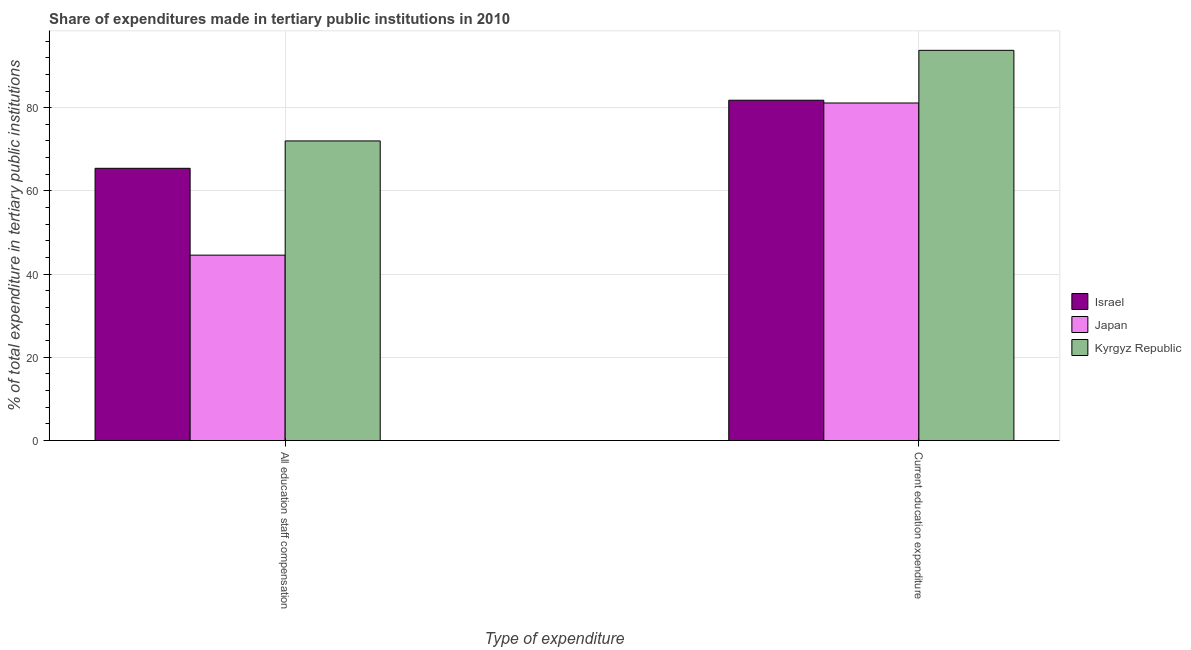How many different coloured bars are there?
Your answer should be compact. 3. How many groups of bars are there?
Give a very brief answer. 2. Are the number of bars on each tick of the X-axis equal?
Your answer should be compact. Yes. What is the label of the 2nd group of bars from the left?
Give a very brief answer. Current education expenditure. What is the expenditure in staff compensation in Japan?
Offer a very short reply. 44.56. Across all countries, what is the maximum expenditure in staff compensation?
Your answer should be compact. 72.01. Across all countries, what is the minimum expenditure in staff compensation?
Ensure brevity in your answer.  44.56. In which country was the expenditure in education maximum?
Your answer should be compact. Kyrgyz Republic. What is the total expenditure in staff compensation in the graph?
Make the answer very short. 181.99. What is the difference between the expenditure in education in Kyrgyz Republic and that in Japan?
Your response must be concise. 12.65. What is the difference between the expenditure in education in Japan and the expenditure in staff compensation in Kyrgyz Republic?
Make the answer very short. 9.12. What is the average expenditure in education per country?
Provide a succinct answer. 85.56. What is the difference between the expenditure in staff compensation and expenditure in education in Kyrgyz Republic?
Your answer should be very brief. -21.77. In how many countries, is the expenditure in education greater than 60 %?
Your answer should be very brief. 3. What is the ratio of the expenditure in education in Japan to that in Kyrgyz Republic?
Provide a succinct answer. 0.87. Is the expenditure in staff compensation in Israel less than that in Japan?
Provide a succinct answer. No. In how many countries, is the expenditure in education greater than the average expenditure in education taken over all countries?
Your answer should be compact. 1. What does the 3rd bar from the left in All education staff compensation represents?
Offer a very short reply. Kyrgyz Republic. How many countries are there in the graph?
Ensure brevity in your answer.  3. Does the graph contain any zero values?
Offer a terse response. No. Where does the legend appear in the graph?
Provide a short and direct response. Center right. What is the title of the graph?
Give a very brief answer. Share of expenditures made in tertiary public institutions in 2010. Does "Slovak Republic" appear as one of the legend labels in the graph?
Your answer should be compact. No. What is the label or title of the X-axis?
Your response must be concise. Type of expenditure. What is the label or title of the Y-axis?
Your answer should be very brief. % of total expenditure in tertiary public institutions. What is the % of total expenditure in tertiary public institutions of Israel in All education staff compensation?
Keep it short and to the point. 65.43. What is the % of total expenditure in tertiary public institutions in Japan in All education staff compensation?
Ensure brevity in your answer.  44.56. What is the % of total expenditure in tertiary public institutions of Kyrgyz Republic in All education staff compensation?
Your response must be concise. 72.01. What is the % of total expenditure in tertiary public institutions in Israel in Current education expenditure?
Offer a terse response. 81.78. What is the % of total expenditure in tertiary public institutions in Japan in Current education expenditure?
Give a very brief answer. 81.12. What is the % of total expenditure in tertiary public institutions of Kyrgyz Republic in Current education expenditure?
Give a very brief answer. 93.77. Across all Type of expenditure, what is the maximum % of total expenditure in tertiary public institutions in Israel?
Your response must be concise. 81.78. Across all Type of expenditure, what is the maximum % of total expenditure in tertiary public institutions in Japan?
Make the answer very short. 81.12. Across all Type of expenditure, what is the maximum % of total expenditure in tertiary public institutions in Kyrgyz Republic?
Ensure brevity in your answer.  93.77. Across all Type of expenditure, what is the minimum % of total expenditure in tertiary public institutions of Israel?
Provide a succinct answer. 65.43. Across all Type of expenditure, what is the minimum % of total expenditure in tertiary public institutions of Japan?
Give a very brief answer. 44.56. Across all Type of expenditure, what is the minimum % of total expenditure in tertiary public institutions of Kyrgyz Republic?
Provide a short and direct response. 72.01. What is the total % of total expenditure in tertiary public institutions in Israel in the graph?
Your answer should be very brief. 147.21. What is the total % of total expenditure in tertiary public institutions of Japan in the graph?
Provide a succinct answer. 125.68. What is the total % of total expenditure in tertiary public institutions in Kyrgyz Republic in the graph?
Ensure brevity in your answer.  165.78. What is the difference between the % of total expenditure in tertiary public institutions of Israel in All education staff compensation and that in Current education expenditure?
Your response must be concise. -16.36. What is the difference between the % of total expenditure in tertiary public institutions in Japan in All education staff compensation and that in Current education expenditure?
Ensure brevity in your answer.  -36.56. What is the difference between the % of total expenditure in tertiary public institutions of Kyrgyz Republic in All education staff compensation and that in Current education expenditure?
Provide a short and direct response. -21.77. What is the difference between the % of total expenditure in tertiary public institutions in Israel in All education staff compensation and the % of total expenditure in tertiary public institutions in Japan in Current education expenditure?
Ensure brevity in your answer.  -15.69. What is the difference between the % of total expenditure in tertiary public institutions of Israel in All education staff compensation and the % of total expenditure in tertiary public institutions of Kyrgyz Republic in Current education expenditure?
Provide a short and direct response. -28.35. What is the difference between the % of total expenditure in tertiary public institutions of Japan in All education staff compensation and the % of total expenditure in tertiary public institutions of Kyrgyz Republic in Current education expenditure?
Provide a succinct answer. -49.22. What is the average % of total expenditure in tertiary public institutions of Israel per Type of expenditure?
Offer a very short reply. 73.61. What is the average % of total expenditure in tertiary public institutions of Japan per Type of expenditure?
Your answer should be very brief. 62.84. What is the average % of total expenditure in tertiary public institutions of Kyrgyz Republic per Type of expenditure?
Offer a very short reply. 82.89. What is the difference between the % of total expenditure in tertiary public institutions of Israel and % of total expenditure in tertiary public institutions of Japan in All education staff compensation?
Provide a short and direct response. 20.87. What is the difference between the % of total expenditure in tertiary public institutions in Israel and % of total expenditure in tertiary public institutions in Kyrgyz Republic in All education staff compensation?
Make the answer very short. -6.58. What is the difference between the % of total expenditure in tertiary public institutions in Japan and % of total expenditure in tertiary public institutions in Kyrgyz Republic in All education staff compensation?
Provide a short and direct response. -27.45. What is the difference between the % of total expenditure in tertiary public institutions in Israel and % of total expenditure in tertiary public institutions in Japan in Current education expenditure?
Offer a terse response. 0.66. What is the difference between the % of total expenditure in tertiary public institutions in Israel and % of total expenditure in tertiary public institutions in Kyrgyz Republic in Current education expenditure?
Offer a terse response. -11.99. What is the difference between the % of total expenditure in tertiary public institutions in Japan and % of total expenditure in tertiary public institutions in Kyrgyz Republic in Current education expenditure?
Ensure brevity in your answer.  -12.65. What is the ratio of the % of total expenditure in tertiary public institutions in Israel in All education staff compensation to that in Current education expenditure?
Your answer should be very brief. 0.8. What is the ratio of the % of total expenditure in tertiary public institutions in Japan in All education staff compensation to that in Current education expenditure?
Provide a short and direct response. 0.55. What is the ratio of the % of total expenditure in tertiary public institutions in Kyrgyz Republic in All education staff compensation to that in Current education expenditure?
Provide a short and direct response. 0.77. What is the difference between the highest and the second highest % of total expenditure in tertiary public institutions in Israel?
Give a very brief answer. 16.36. What is the difference between the highest and the second highest % of total expenditure in tertiary public institutions of Japan?
Your answer should be very brief. 36.56. What is the difference between the highest and the second highest % of total expenditure in tertiary public institutions of Kyrgyz Republic?
Offer a very short reply. 21.77. What is the difference between the highest and the lowest % of total expenditure in tertiary public institutions in Israel?
Provide a succinct answer. 16.36. What is the difference between the highest and the lowest % of total expenditure in tertiary public institutions in Japan?
Provide a short and direct response. 36.56. What is the difference between the highest and the lowest % of total expenditure in tertiary public institutions of Kyrgyz Republic?
Your response must be concise. 21.77. 